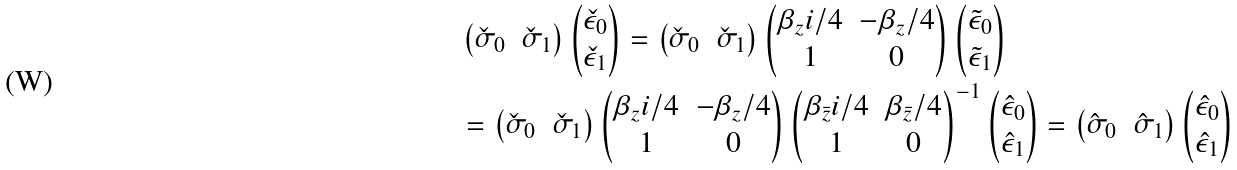Convert formula to latex. <formula><loc_0><loc_0><loc_500><loc_500>& \begin{pmatrix} \check { \sigma } _ { 0 } & \check { \sigma } _ { 1 } \end{pmatrix} \begin{pmatrix} \check { \epsilon } _ { 0 } \\ \check { \epsilon } _ { 1 } \end{pmatrix} = \begin{pmatrix} \check { \sigma } _ { 0 } & \check { \sigma } _ { 1 } \end{pmatrix} \begin{pmatrix} \beta _ { z } i / 4 & - \beta _ { z } / 4 \\ 1 & 0 \end{pmatrix} \begin{pmatrix} \tilde { \epsilon } _ { 0 } \\ \tilde { \epsilon } _ { 1 } \end{pmatrix} \\ & = \begin{pmatrix} \check { \sigma } _ { 0 } & \check { \sigma } _ { 1 } \end{pmatrix} \begin{pmatrix} \beta _ { z } i / 4 & - \beta _ { z } / 4 \\ 1 & 0 \end{pmatrix} \begin{pmatrix} \beta _ { \bar { z } } i / 4 & \beta _ { \bar { z } } / 4 \\ 1 & 0 \end{pmatrix} ^ { - 1 } \begin{pmatrix} \hat { \epsilon } _ { 0 } \\ \hat { \epsilon } _ { 1 } \end{pmatrix} = \begin{pmatrix} \hat { \sigma } _ { 0 } & \hat { \sigma } _ { 1 } \end{pmatrix} \begin{pmatrix} \hat { \epsilon } _ { 0 } \\ \hat { \epsilon } _ { 1 } \end{pmatrix}</formula> 